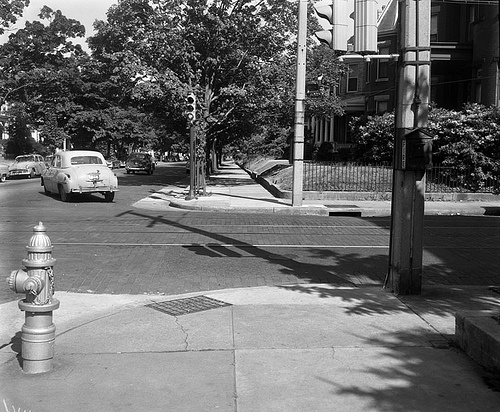<image>What traffic light is on? I don't know what traffic light is on. It could be green or red. What traffic light is on? I don't know which traffic light is on. It could be either green or red. 